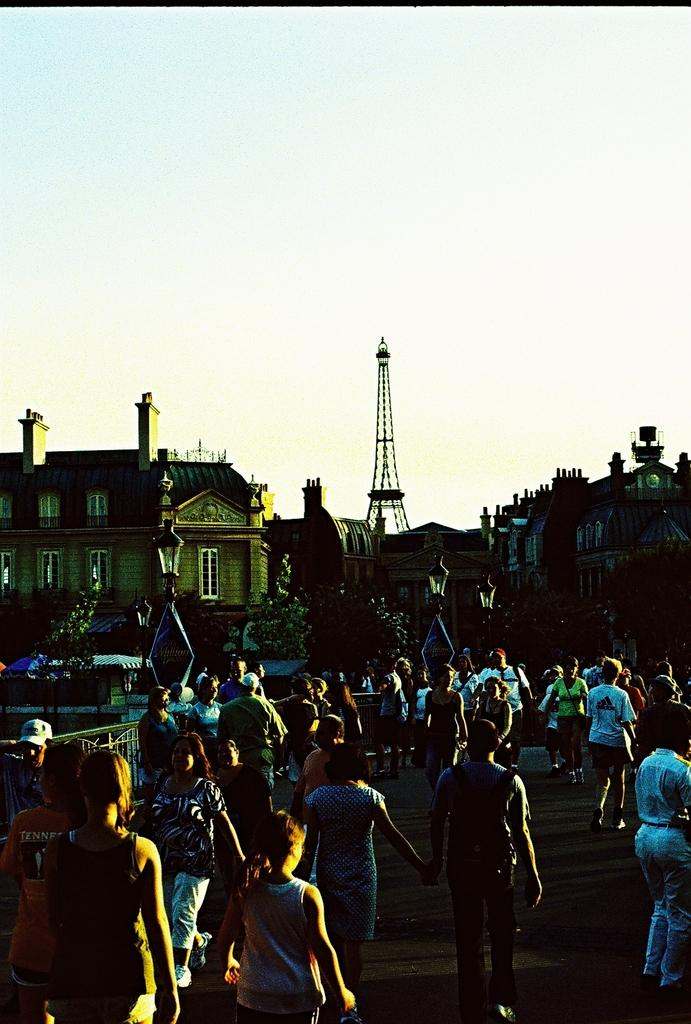What is happening in the image? There are many people on the road in the image. What can be seen in the distance in the image? There are buildings, towers, and street lights in the background of the image. How would you describe the lighting in the image? The background of the image is dark. Can you tell me how many people are joining the middle of the road in the image? There is no indication in the image that people are joining the middle of the road; they are already present on the road. What type of thing is being used to connect the towers in the image? There is no visible connection between the towers in the image. 